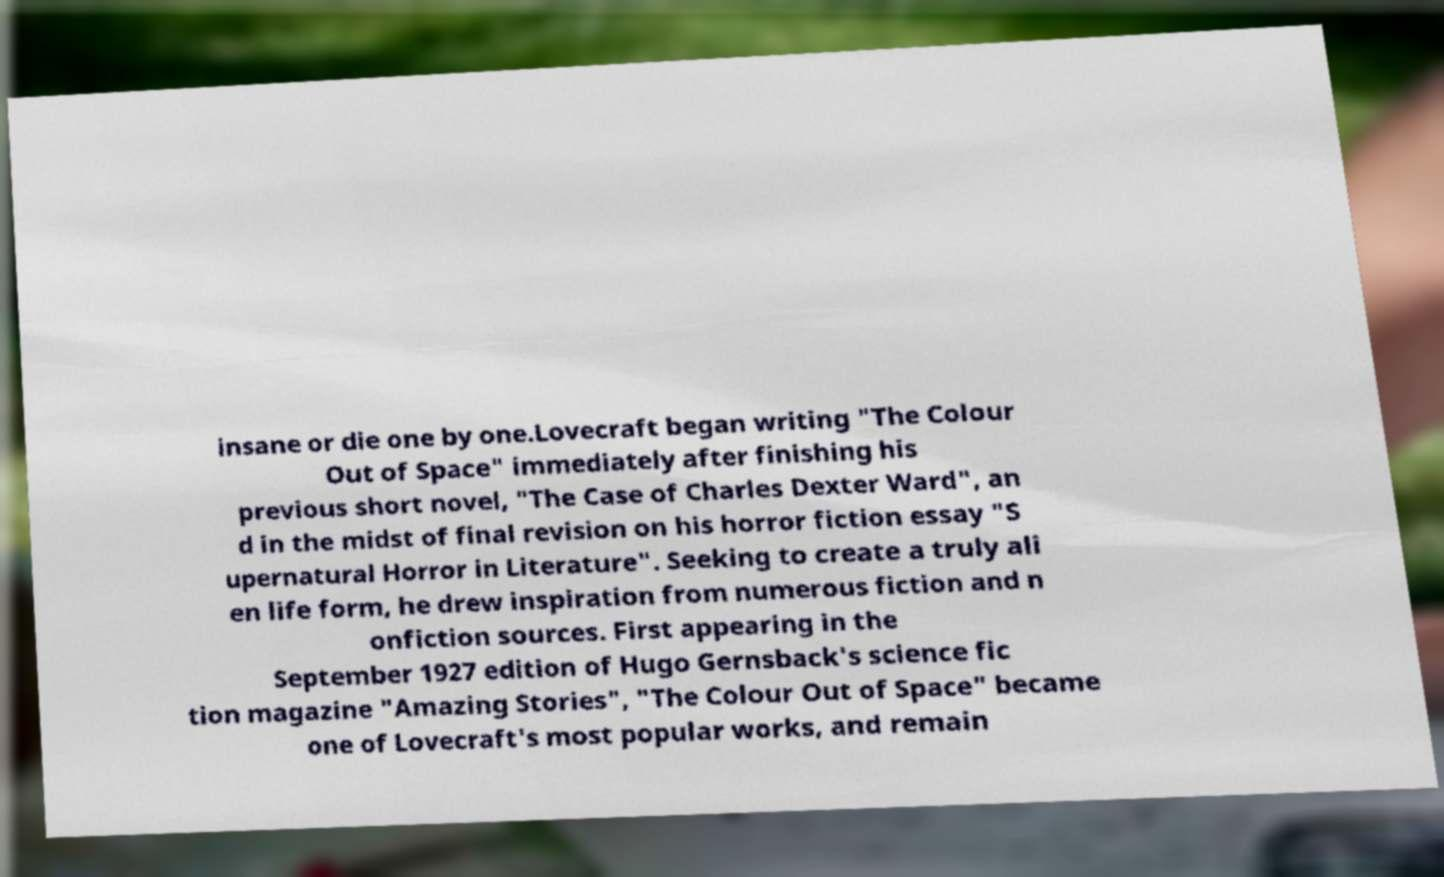Can you accurately transcribe the text from the provided image for me? insane or die one by one.Lovecraft began writing "The Colour Out of Space" immediately after finishing his previous short novel, "The Case of Charles Dexter Ward", an d in the midst of final revision on his horror fiction essay "S upernatural Horror in Literature". Seeking to create a truly ali en life form, he drew inspiration from numerous fiction and n onfiction sources. First appearing in the September 1927 edition of Hugo Gernsback's science fic tion magazine "Amazing Stories", "The Colour Out of Space" became one of Lovecraft's most popular works, and remain 